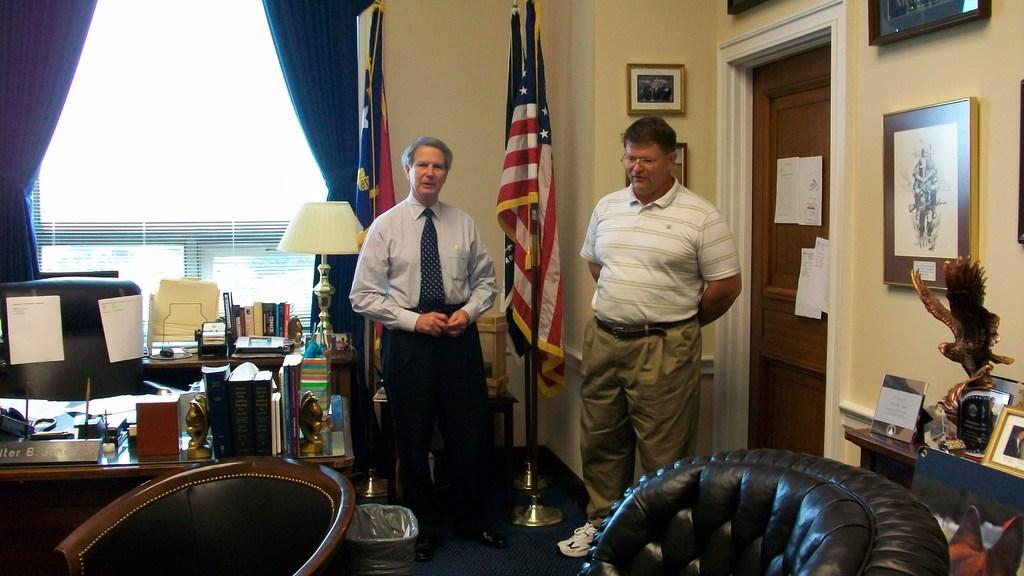What is happening in the image? There are people standing in the image. What objects can be seen on the table in the image? There are books and a statue of a toy on the table in the image. What is the flag used for in the image? The flag's purpose is not specified in the image, but it is visible. Where is the kitty playing with a branch in the image? There is no kitty or branch present in the image. What type of vessel is being used by the people in the image? The image does not show any vessels being used by the people. 